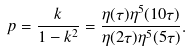Convert formula to latex. <formula><loc_0><loc_0><loc_500><loc_500>p = \frac { k } { 1 - k ^ { 2 } } = \frac { \eta ( \tau ) \eta ^ { 5 } ( 1 0 \tau ) } { \eta ( 2 \tau ) \eta ^ { 5 } ( 5 \tau ) } .</formula> 